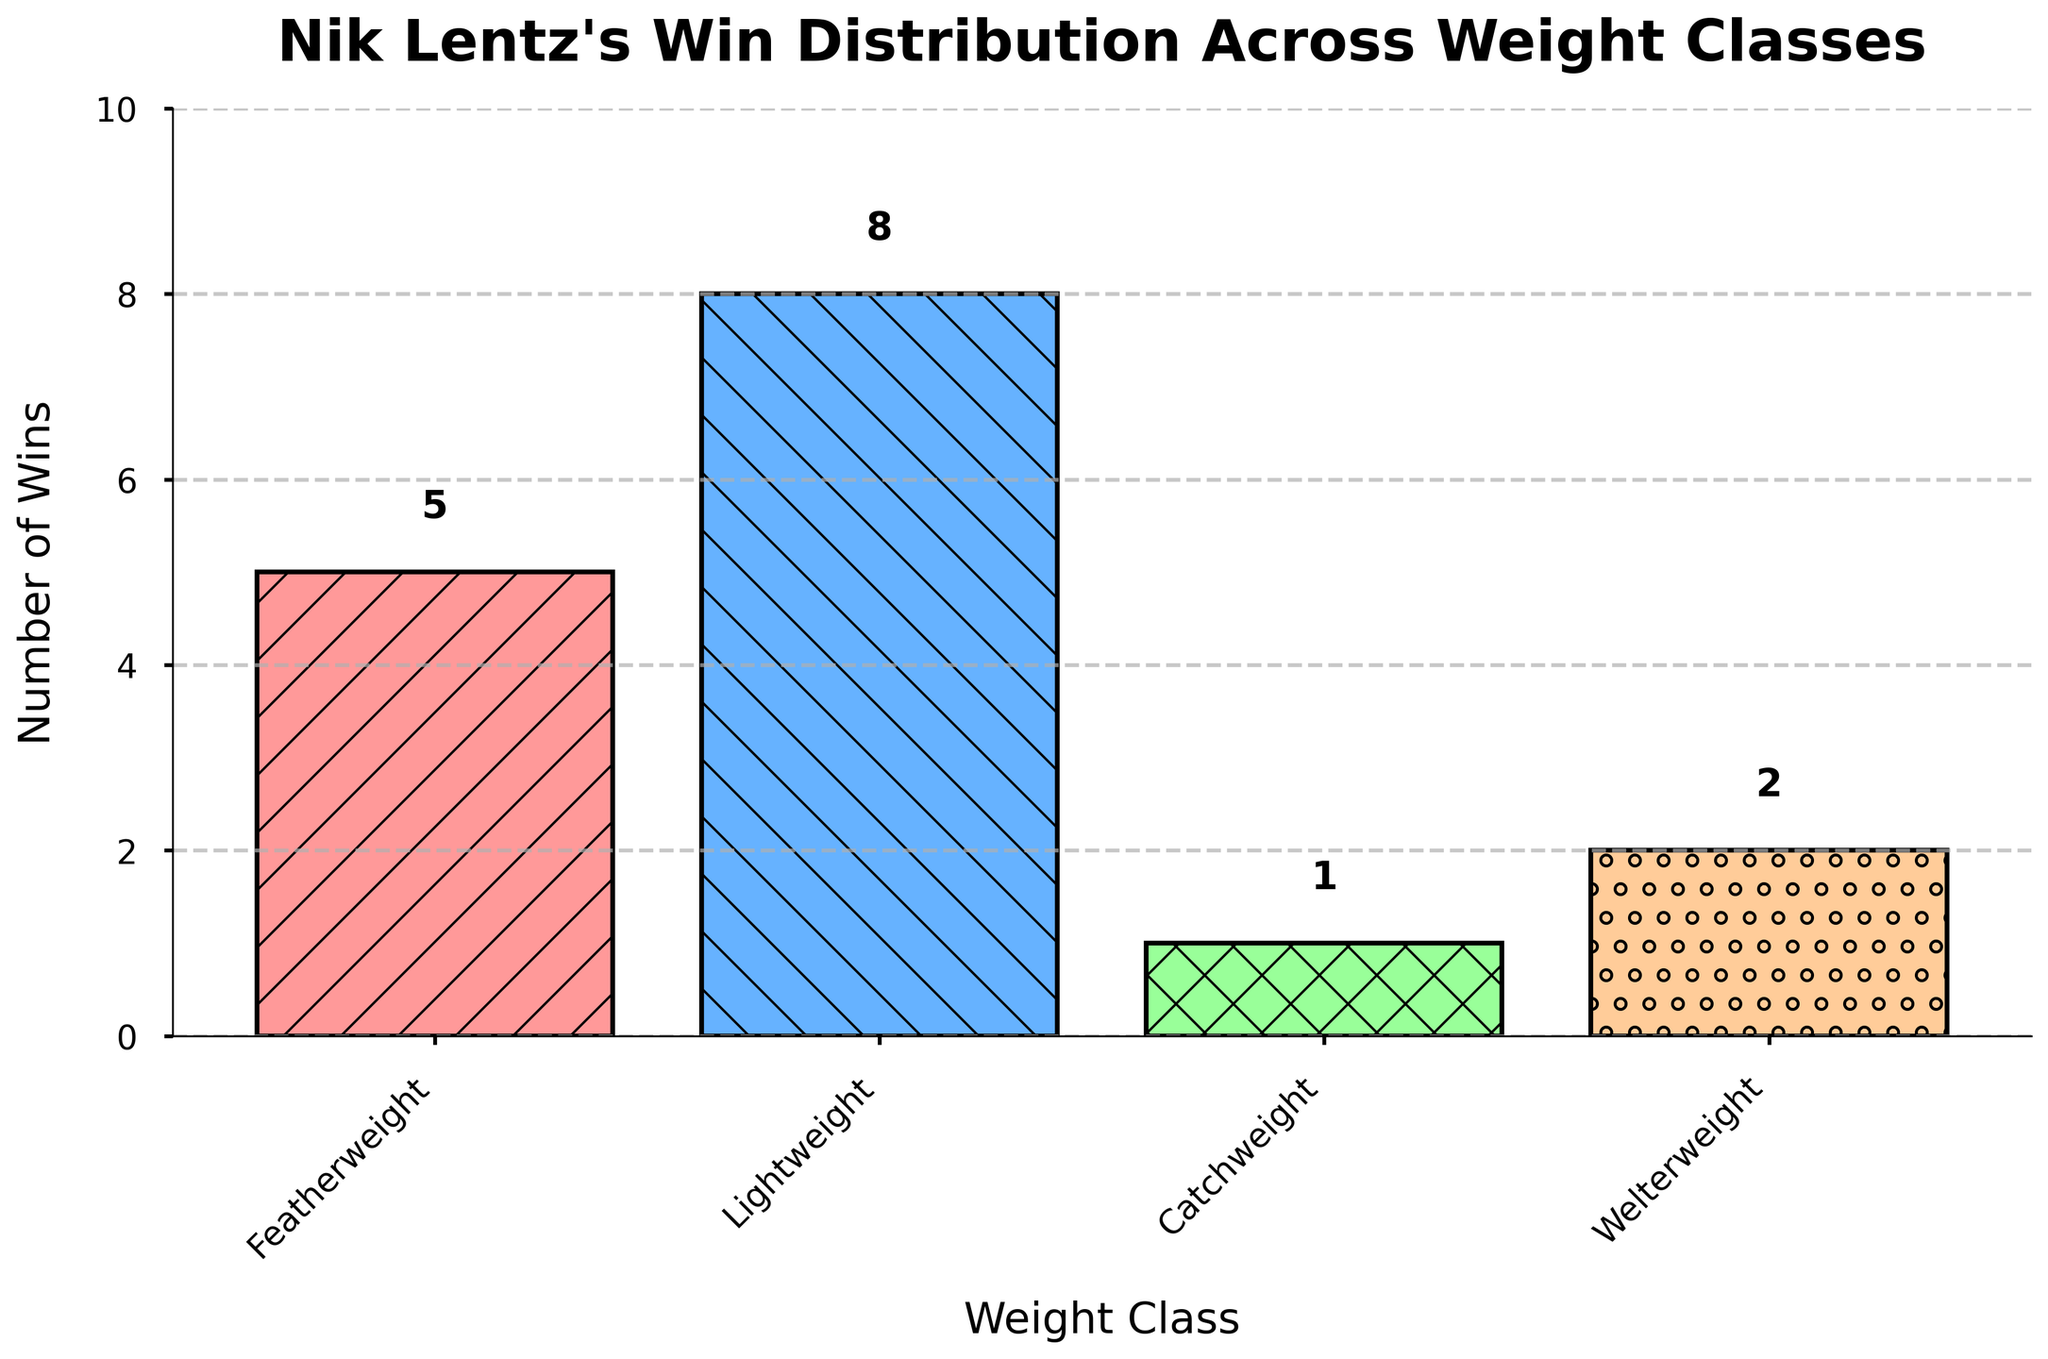Which weight class does Nik Lentz have the most wins in? Observing the heights of the bars, the one for "Lightweight" is the tallest, indicating the highest number of wins in this category.
Answer: Lightweight How many more wins does Nik Lentz have in Lightweight than in Featherweight? The number of wins in Lightweight is 8 and in Featherweight is 5. The difference is 8 - 5 = 3.
Answer: 3 What is the total number of wins across all weight classes? Sum the wins in all weight classes: 5 (Featherweight) + 8 (Lightweight) + 1 (Catchweight) + 2 (Welterweight) = 16.
Answer: 16 Which weight class has the fewest wins? The shortest bar represents "Catchweight" with only 1 win.
Answer: Catchweight What is the combined total of wins in Featherweight and Welterweight? Add the wins in Featherweight (5) and Welterweight (2): 5 + 2 = 7.
Answer: 7 Are there more wins in Welterweight or in Catchweight? Comparing the bars, Welterweight has 2 wins while Catchweight has 1 win. Thus, Welterweight has more wins.
Answer: Welterweight How many wins does Nik Lentz have in weight classes other than Lightweight? Sum the wins in Featherweight, Catchweight, and Welterweight: 5 + 1 + 2 = 8.
Answer: 8 What percentage of his total wins are in the Lightweight class? Total wins are 16. Wins in Lightweight are 8. Percentage is (8/16) * 100 = 50%.
Answer: 50% By how much do the wins in Lightweight differ from the total wins in Featherweight and Welterweight combined? Lightweight has 8 wins. Featherweight and Welterweight combined have 7 wins (5 + 2). The difference is 8 - 7 = 1.
Answer: 1 